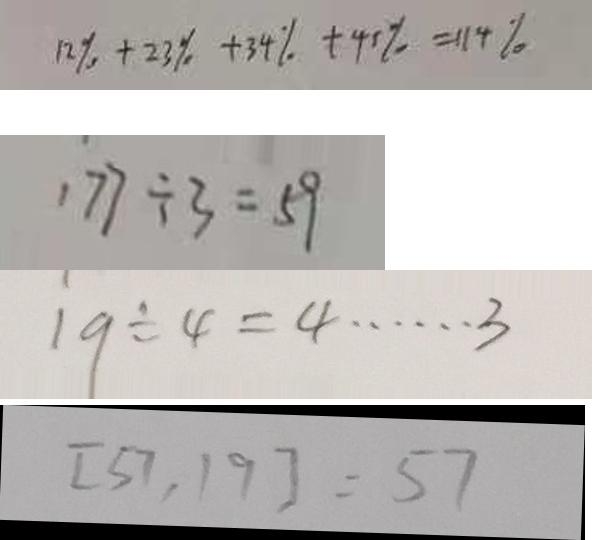<formula> <loc_0><loc_0><loc_500><loc_500>1 2 \% + 2 3 \% + 3 4 \% + 4 5 \% = 1 1 4 \% 
 1 7 7 \div 3 = 5 9 
 1 9 \div 4 = 4 \dot s \dot s 3 
 [ 5 7 , 1 9 ] = 5 7</formula> 